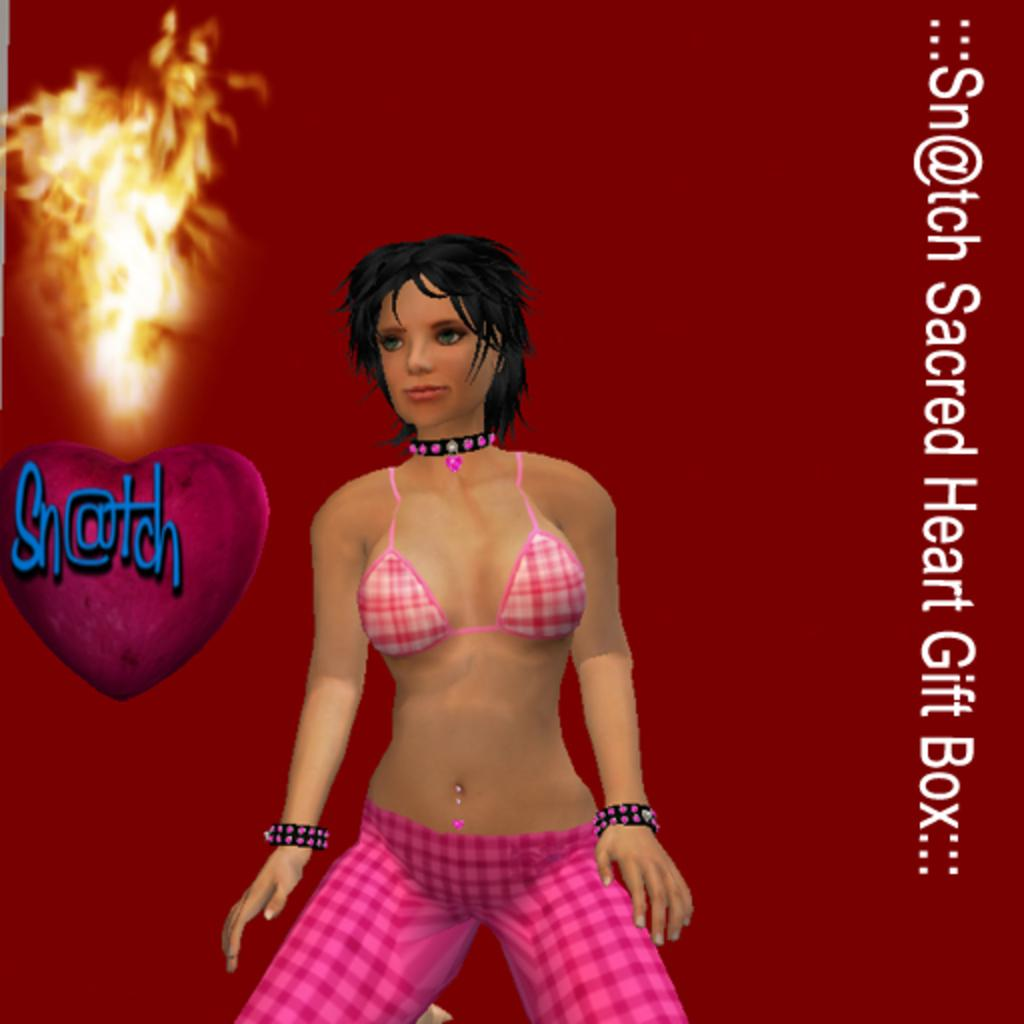What type of image is being described? The image is an animation. Can you describe the person in the image? There is a person standing in the image. What else is present in the image besides the person? There is text and a fire in the image. What is the opinion of the person in the image about the lock? There is no lock present in the image, and therefore no opinion about it can be determined. 